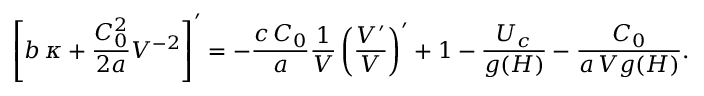<formula> <loc_0><loc_0><loc_500><loc_500>\left [ b \, \kappa + \frac { C _ { 0 } ^ { 2 } } { 2 a } V ^ { - 2 } \right ] ^ { \prime } = - \frac { c \, C _ { 0 } } { a } \frac { 1 } { V } \left ( \frac { V ^ { \prime } } { V } \right ) ^ { \prime } + 1 - \frac { U _ { c } } { g ( H ) } - \frac { C _ { 0 } } { a \, V g ( H ) } .</formula> 